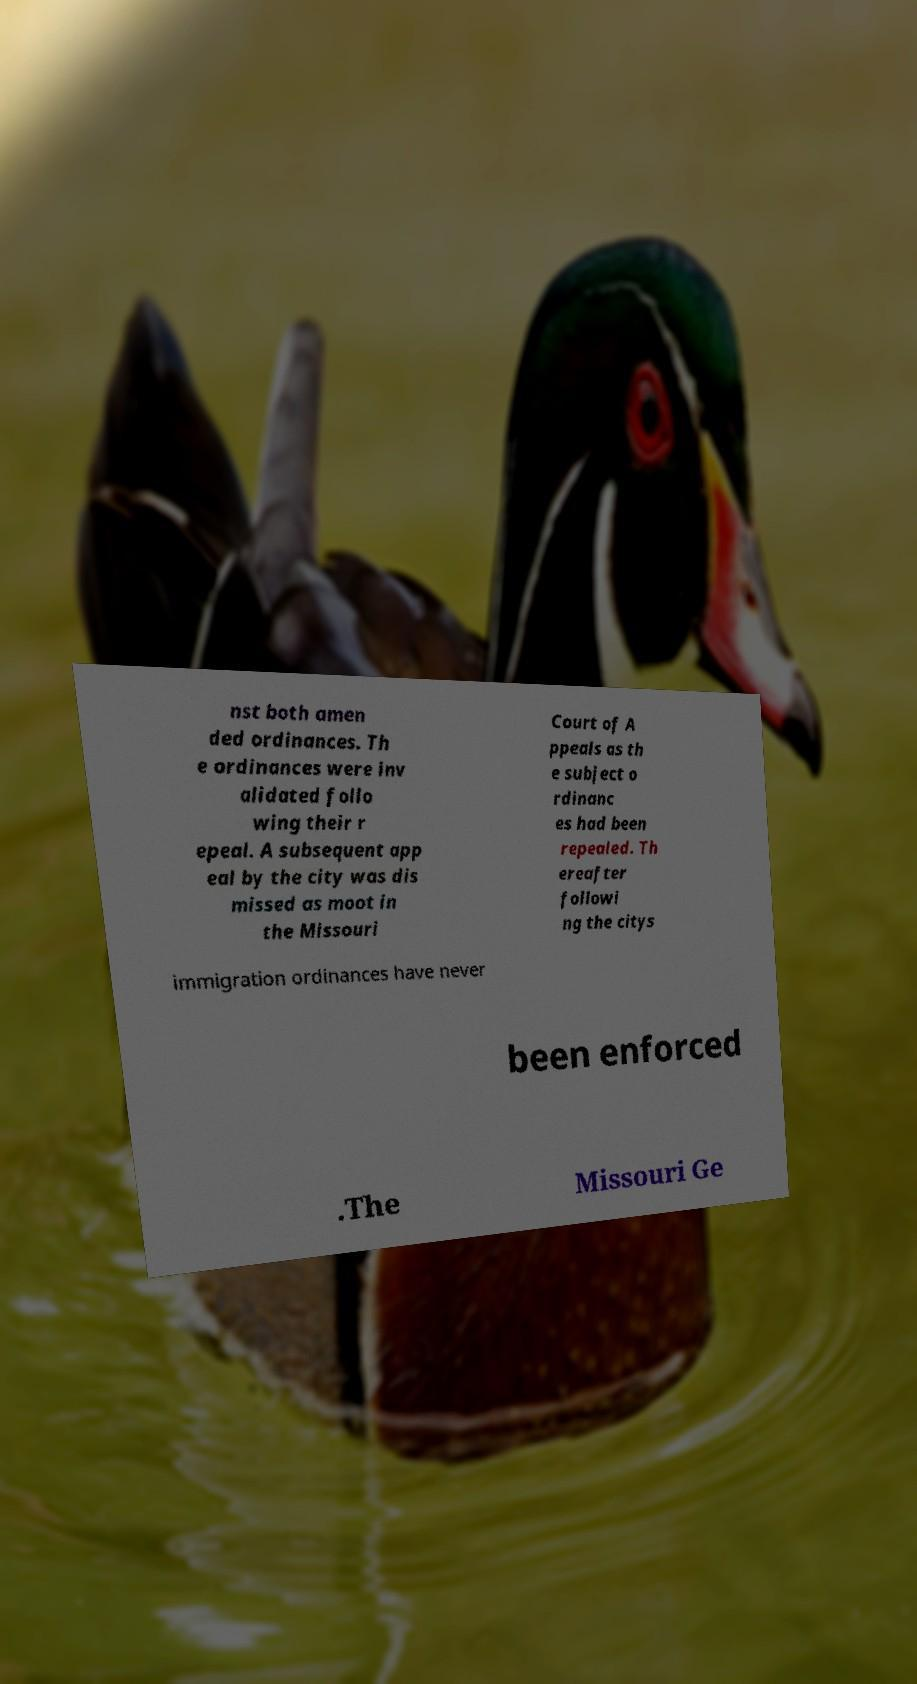Can you accurately transcribe the text from the provided image for me? nst both amen ded ordinances. Th e ordinances were inv alidated follo wing their r epeal. A subsequent app eal by the city was dis missed as moot in the Missouri Court of A ppeals as th e subject o rdinanc es had been repealed. Th ereafter followi ng the citys immigration ordinances have never been enforced .The Missouri Ge 